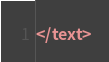Convert code to text. <code><loc_0><loc_0><loc_500><loc_500><_XML_></text>
</code> 